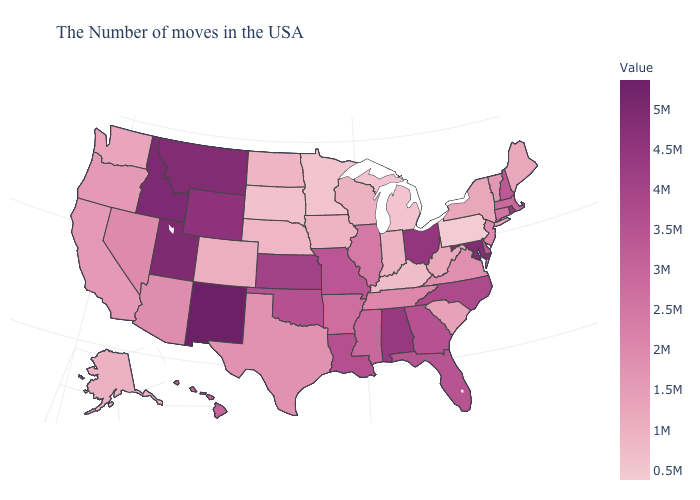Does Pennsylvania have the lowest value in the USA?
Be succinct. Yes. Does Washington have a lower value than Florida?
Write a very short answer. Yes. Among the states that border Delaware , which have the highest value?
Be succinct. Maryland. Among the states that border Massachusetts , does Vermont have the lowest value?
Short answer required. No. 